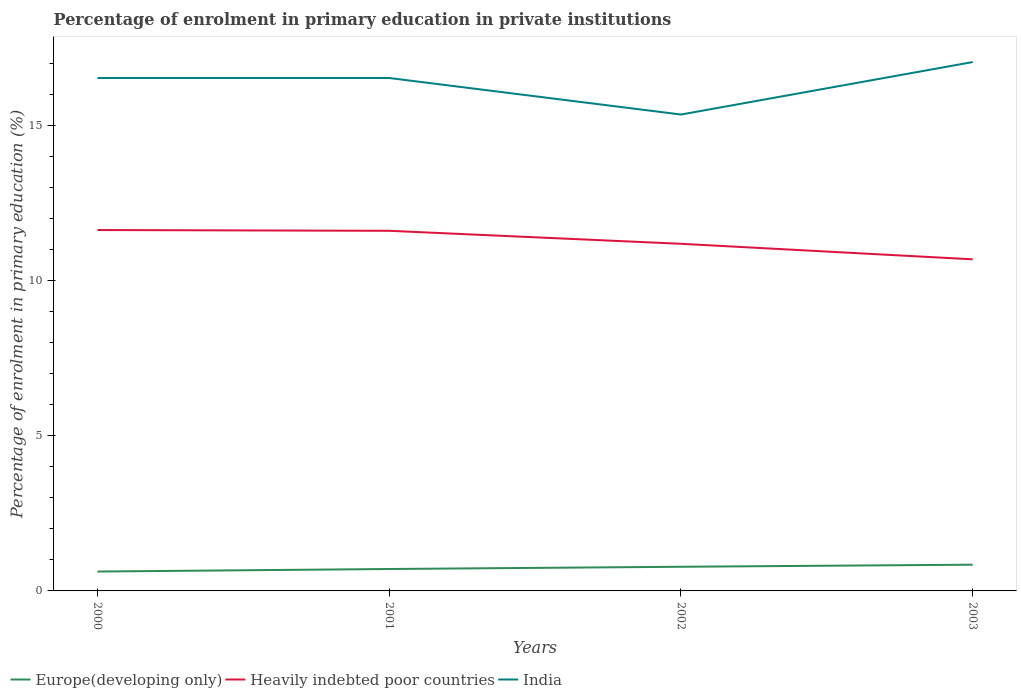Across all years, what is the maximum percentage of enrolment in primary education in Heavily indebted poor countries?
Your answer should be compact. 10.69. What is the total percentage of enrolment in primary education in Heavily indebted poor countries in the graph?
Give a very brief answer. 0.42. What is the difference between the highest and the second highest percentage of enrolment in primary education in India?
Make the answer very short. 1.69. How many years are there in the graph?
Your answer should be compact. 4. What is the difference between two consecutive major ticks on the Y-axis?
Provide a short and direct response. 5. Are the values on the major ticks of Y-axis written in scientific E-notation?
Provide a succinct answer. No. Does the graph contain any zero values?
Provide a succinct answer. No. How are the legend labels stacked?
Offer a terse response. Horizontal. What is the title of the graph?
Offer a terse response. Percentage of enrolment in primary education in private institutions. What is the label or title of the X-axis?
Ensure brevity in your answer.  Years. What is the label or title of the Y-axis?
Give a very brief answer. Percentage of enrolment in primary education (%). What is the Percentage of enrolment in primary education (%) of Europe(developing only) in 2000?
Your response must be concise. 0.62. What is the Percentage of enrolment in primary education (%) of Heavily indebted poor countries in 2000?
Offer a terse response. 11.63. What is the Percentage of enrolment in primary education (%) in India in 2000?
Provide a succinct answer. 16.53. What is the Percentage of enrolment in primary education (%) of Europe(developing only) in 2001?
Offer a very short reply. 0.71. What is the Percentage of enrolment in primary education (%) in Heavily indebted poor countries in 2001?
Keep it short and to the point. 11.61. What is the Percentage of enrolment in primary education (%) in India in 2001?
Make the answer very short. 16.53. What is the Percentage of enrolment in primary education (%) of Europe(developing only) in 2002?
Your answer should be compact. 0.78. What is the Percentage of enrolment in primary education (%) in Heavily indebted poor countries in 2002?
Offer a very short reply. 11.19. What is the Percentage of enrolment in primary education (%) in India in 2002?
Provide a succinct answer. 15.35. What is the Percentage of enrolment in primary education (%) of Europe(developing only) in 2003?
Offer a terse response. 0.85. What is the Percentage of enrolment in primary education (%) in Heavily indebted poor countries in 2003?
Your answer should be compact. 10.69. What is the Percentage of enrolment in primary education (%) of India in 2003?
Provide a short and direct response. 17.04. Across all years, what is the maximum Percentage of enrolment in primary education (%) in Europe(developing only)?
Provide a succinct answer. 0.85. Across all years, what is the maximum Percentage of enrolment in primary education (%) of Heavily indebted poor countries?
Offer a terse response. 11.63. Across all years, what is the maximum Percentage of enrolment in primary education (%) in India?
Provide a short and direct response. 17.04. Across all years, what is the minimum Percentage of enrolment in primary education (%) of Europe(developing only)?
Provide a short and direct response. 0.62. Across all years, what is the minimum Percentage of enrolment in primary education (%) in Heavily indebted poor countries?
Your answer should be very brief. 10.69. Across all years, what is the minimum Percentage of enrolment in primary education (%) in India?
Ensure brevity in your answer.  15.35. What is the total Percentage of enrolment in primary education (%) of Europe(developing only) in the graph?
Offer a very short reply. 2.95. What is the total Percentage of enrolment in primary education (%) of Heavily indebted poor countries in the graph?
Provide a short and direct response. 45.11. What is the total Percentage of enrolment in primary education (%) of India in the graph?
Offer a very short reply. 65.46. What is the difference between the Percentage of enrolment in primary education (%) in Europe(developing only) in 2000 and that in 2001?
Your answer should be very brief. -0.08. What is the difference between the Percentage of enrolment in primary education (%) of Heavily indebted poor countries in 2000 and that in 2001?
Provide a succinct answer. 0.02. What is the difference between the Percentage of enrolment in primary education (%) of Europe(developing only) in 2000 and that in 2002?
Provide a succinct answer. -0.15. What is the difference between the Percentage of enrolment in primary education (%) of Heavily indebted poor countries in 2000 and that in 2002?
Make the answer very short. 0.44. What is the difference between the Percentage of enrolment in primary education (%) of India in 2000 and that in 2002?
Offer a very short reply. 1.18. What is the difference between the Percentage of enrolment in primary education (%) of Europe(developing only) in 2000 and that in 2003?
Offer a very short reply. -0.22. What is the difference between the Percentage of enrolment in primary education (%) of Heavily indebted poor countries in 2000 and that in 2003?
Your response must be concise. 0.94. What is the difference between the Percentage of enrolment in primary education (%) in India in 2000 and that in 2003?
Provide a succinct answer. -0.51. What is the difference between the Percentage of enrolment in primary education (%) in Europe(developing only) in 2001 and that in 2002?
Your answer should be compact. -0.07. What is the difference between the Percentage of enrolment in primary education (%) of Heavily indebted poor countries in 2001 and that in 2002?
Offer a very short reply. 0.42. What is the difference between the Percentage of enrolment in primary education (%) in India in 2001 and that in 2002?
Give a very brief answer. 1.18. What is the difference between the Percentage of enrolment in primary education (%) in Europe(developing only) in 2001 and that in 2003?
Provide a short and direct response. -0.14. What is the difference between the Percentage of enrolment in primary education (%) in Heavily indebted poor countries in 2001 and that in 2003?
Keep it short and to the point. 0.92. What is the difference between the Percentage of enrolment in primary education (%) in India in 2001 and that in 2003?
Offer a very short reply. -0.51. What is the difference between the Percentage of enrolment in primary education (%) in Europe(developing only) in 2002 and that in 2003?
Your response must be concise. -0.07. What is the difference between the Percentage of enrolment in primary education (%) in Heavily indebted poor countries in 2002 and that in 2003?
Your answer should be compact. 0.5. What is the difference between the Percentage of enrolment in primary education (%) in India in 2002 and that in 2003?
Give a very brief answer. -1.69. What is the difference between the Percentage of enrolment in primary education (%) of Europe(developing only) in 2000 and the Percentage of enrolment in primary education (%) of Heavily indebted poor countries in 2001?
Give a very brief answer. -10.98. What is the difference between the Percentage of enrolment in primary education (%) of Europe(developing only) in 2000 and the Percentage of enrolment in primary education (%) of India in 2001?
Provide a succinct answer. -15.91. What is the difference between the Percentage of enrolment in primary education (%) in Heavily indebted poor countries in 2000 and the Percentage of enrolment in primary education (%) in India in 2001?
Provide a succinct answer. -4.9. What is the difference between the Percentage of enrolment in primary education (%) of Europe(developing only) in 2000 and the Percentage of enrolment in primary education (%) of Heavily indebted poor countries in 2002?
Offer a terse response. -10.56. What is the difference between the Percentage of enrolment in primary education (%) in Europe(developing only) in 2000 and the Percentage of enrolment in primary education (%) in India in 2002?
Your answer should be compact. -14.73. What is the difference between the Percentage of enrolment in primary education (%) of Heavily indebted poor countries in 2000 and the Percentage of enrolment in primary education (%) of India in 2002?
Make the answer very short. -3.72. What is the difference between the Percentage of enrolment in primary education (%) in Europe(developing only) in 2000 and the Percentage of enrolment in primary education (%) in Heavily indebted poor countries in 2003?
Ensure brevity in your answer.  -10.06. What is the difference between the Percentage of enrolment in primary education (%) in Europe(developing only) in 2000 and the Percentage of enrolment in primary education (%) in India in 2003?
Provide a short and direct response. -16.42. What is the difference between the Percentage of enrolment in primary education (%) of Heavily indebted poor countries in 2000 and the Percentage of enrolment in primary education (%) of India in 2003?
Offer a terse response. -5.41. What is the difference between the Percentage of enrolment in primary education (%) in Europe(developing only) in 2001 and the Percentage of enrolment in primary education (%) in Heavily indebted poor countries in 2002?
Give a very brief answer. -10.48. What is the difference between the Percentage of enrolment in primary education (%) in Europe(developing only) in 2001 and the Percentage of enrolment in primary education (%) in India in 2002?
Give a very brief answer. -14.65. What is the difference between the Percentage of enrolment in primary education (%) of Heavily indebted poor countries in 2001 and the Percentage of enrolment in primary education (%) of India in 2002?
Give a very brief answer. -3.75. What is the difference between the Percentage of enrolment in primary education (%) of Europe(developing only) in 2001 and the Percentage of enrolment in primary education (%) of Heavily indebted poor countries in 2003?
Your response must be concise. -9.98. What is the difference between the Percentage of enrolment in primary education (%) of Europe(developing only) in 2001 and the Percentage of enrolment in primary education (%) of India in 2003?
Your answer should be very brief. -16.34. What is the difference between the Percentage of enrolment in primary education (%) in Heavily indebted poor countries in 2001 and the Percentage of enrolment in primary education (%) in India in 2003?
Make the answer very short. -5.44. What is the difference between the Percentage of enrolment in primary education (%) of Europe(developing only) in 2002 and the Percentage of enrolment in primary education (%) of Heavily indebted poor countries in 2003?
Make the answer very short. -9.91. What is the difference between the Percentage of enrolment in primary education (%) in Europe(developing only) in 2002 and the Percentage of enrolment in primary education (%) in India in 2003?
Make the answer very short. -16.27. What is the difference between the Percentage of enrolment in primary education (%) of Heavily indebted poor countries in 2002 and the Percentage of enrolment in primary education (%) of India in 2003?
Keep it short and to the point. -5.86. What is the average Percentage of enrolment in primary education (%) of Europe(developing only) per year?
Ensure brevity in your answer.  0.74. What is the average Percentage of enrolment in primary education (%) in Heavily indebted poor countries per year?
Your answer should be very brief. 11.28. What is the average Percentage of enrolment in primary education (%) of India per year?
Provide a succinct answer. 16.36. In the year 2000, what is the difference between the Percentage of enrolment in primary education (%) of Europe(developing only) and Percentage of enrolment in primary education (%) of Heavily indebted poor countries?
Your response must be concise. -11.01. In the year 2000, what is the difference between the Percentage of enrolment in primary education (%) of Europe(developing only) and Percentage of enrolment in primary education (%) of India?
Make the answer very short. -15.91. In the year 2000, what is the difference between the Percentage of enrolment in primary education (%) in Heavily indebted poor countries and Percentage of enrolment in primary education (%) in India?
Offer a very short reply. -4.9. In the year 2001, what is the difference between the Percentage of enrolment in primary education (%) in Europe(developing only) and Percentage of enrolment in primary education (%) in Heavily indebted poor countries?
Your response must be concise. -10.9. In the year 2001, what is the difference between the Percentage of enrolment in primary education (%) of Europe(developing only) and Percentage of enrolment in primary education (%) of India?
Offer a very short reply. -15.82. In the year 2001, what is the difference between the Percentage of enrolment in primary education (%) in Heavily indebted poor countries and Percentage of enrolment in primary education (%) in India?
Your answer should be compact. -4.92. In the year 2002, what is the difference between the Percentage of enrolment in primary education (%) in Europe(developing only) and Percentage of enrolment in primary education (%) in Heavily indebted poor countries?
Provide a short and direct response. -10.41. In the year 2002, what is the difference between the Percentage of enrolment in primary education (%) of Europe(developing only) and Percentage of enrolment in primary education (%) of India?
Offer a terse response. -14.57. In the year 2002, what is the difference between the Percentage of enrolment in primary education (%) of Heavily indebted poor countries and Percentage of enrolment in primary education (%) of India?
Provide a succinct answer. -4.17. In the year 2003, what is the difference between the Percentage of enrolment in primary education (%) of Europe(developing only) and Percentage of enrolment in primary education (%) of Heavily indebted poor countries?
Ensure brevity in your answer.  -9.84. In the year 2003, what is the difference between the Percentage of enrolment in primary education (%) in Europe(developing only) and Percentage of enrolment in primary education (%) in India?
Give a very brief answer. -16.2. In the year 2003, what is the difference between the Percentage of enrolment in primary education (%) of Heavily indebted poor countries and Percentage of enrolment in primary education (%) of India?
Offer a very short reply. -6.36. What is the ratio of the Percentage of enrolment in primary education (%) in Europe(developing only) in 2000 to that in 2001?
Your answer should be very brief. 0.88. What is the ratio of the Percentage of enrolment in primary education (%) of Europe(developing only) in 2000 to that in 2002?
Your answer should be compact. 0.8. What is the ratio of the Percentage of enrolment in primary education (%) of Heavily indebted poor countries in 2000 to that in 2002?
Offer a terse response. 1.04. What is the ratio of the Percentage of enrolment in primary education (%) of India in 2000 to that in 2002?
Your answer should be very brief. 1.08. What is the ratio of the Percentage of enrolment in primary education (%) of Europe(developing only) in 2000 to that in 2003?
Provide a succinct answer. 0.74. What is the ratio of the Percentage of enrolment in primary education (%) in Heavily indebted poor countries in 2000 to that in 2003?
Your response must be concise. 1.09. What is the ratio of the Percentage of enrolment in primary education (%) in India in 2000 to that in 2003?
Give a very brief answer. 0.97. What is the ratio of the Percentage of enrolment in primary education (%) of Europe(developing only) in 2001 to that in 2002?
Keep it short and to the point. 0.91. What is the ratio of the Percentage of enrolment in primary education (%) of Heavily indebted poor countries in 2001 to that in 2002?
Offer a very short reply. 1.04. What is the ratio of the Percentage of enrolment in primary education (%) in India in 2001 to that in 2002?
Ensure brevity in your answer.  1.08. What is the ratio of the Percentage of enrolment in primary education (%) in Europe(developing only) in 2001 to that in 2003?
Provide a short and direct response. 0.84. What is the ratio of the Percentage of enrolment in primary education (%) in Heavily indebted poor countries in 2001 to that in 2003?
Offer a very short reply. 1.09. What is the ratio of the Percentage of enrolment in primary education (%) in India in 2001 to that in 2003?
Provide a short and direct response. 0.97. What is the ratio of the Percentage of enrolment in primary education (%) in Europe(developing only) in 2002 to that in 2003?
Provide a short and direct response. 0.92. What is the ratio of the Percentage of enrolment in primary education (%) of Heavily indebted poor countries in 2002 to that in 2003?
Make the answer very short. 1.05. What is the ratio of the Percentage of enrolment in primary education (%) of India in 2002 to that in 2003?
Your answer should be very brief. 0.9. What is the difference between the highest and the second highest Percentage of enrolment in primary education (%) in Europe(developing only)?
Keep it short and to the point. 0.07. What is the difference between the highest and the second highest Percentage of enrolment in primary education (%) of Heavily indebted poor countries?
Offer a terse response. 0.02. What is the difference between the highest and the second highest Percentage of enrolment in primary education (%) of India?
Keep it short and to the point. 0.51. What is the difference between the highest and the lowest Percentage of enrolment in primary education (%) of Europe(developing only)?
Ensure brevity in your answer.  0.22. What is the difference between the highest and the lowest Percentage of enrolment in primary education (%) in Heavily indebted poor countries?
Ensure brevity in your answer.  0.94. What is the difference between the highest and the lowest Percentage of enrolment in primary education (%) of India?
Offer a very short reply. 1.69. 